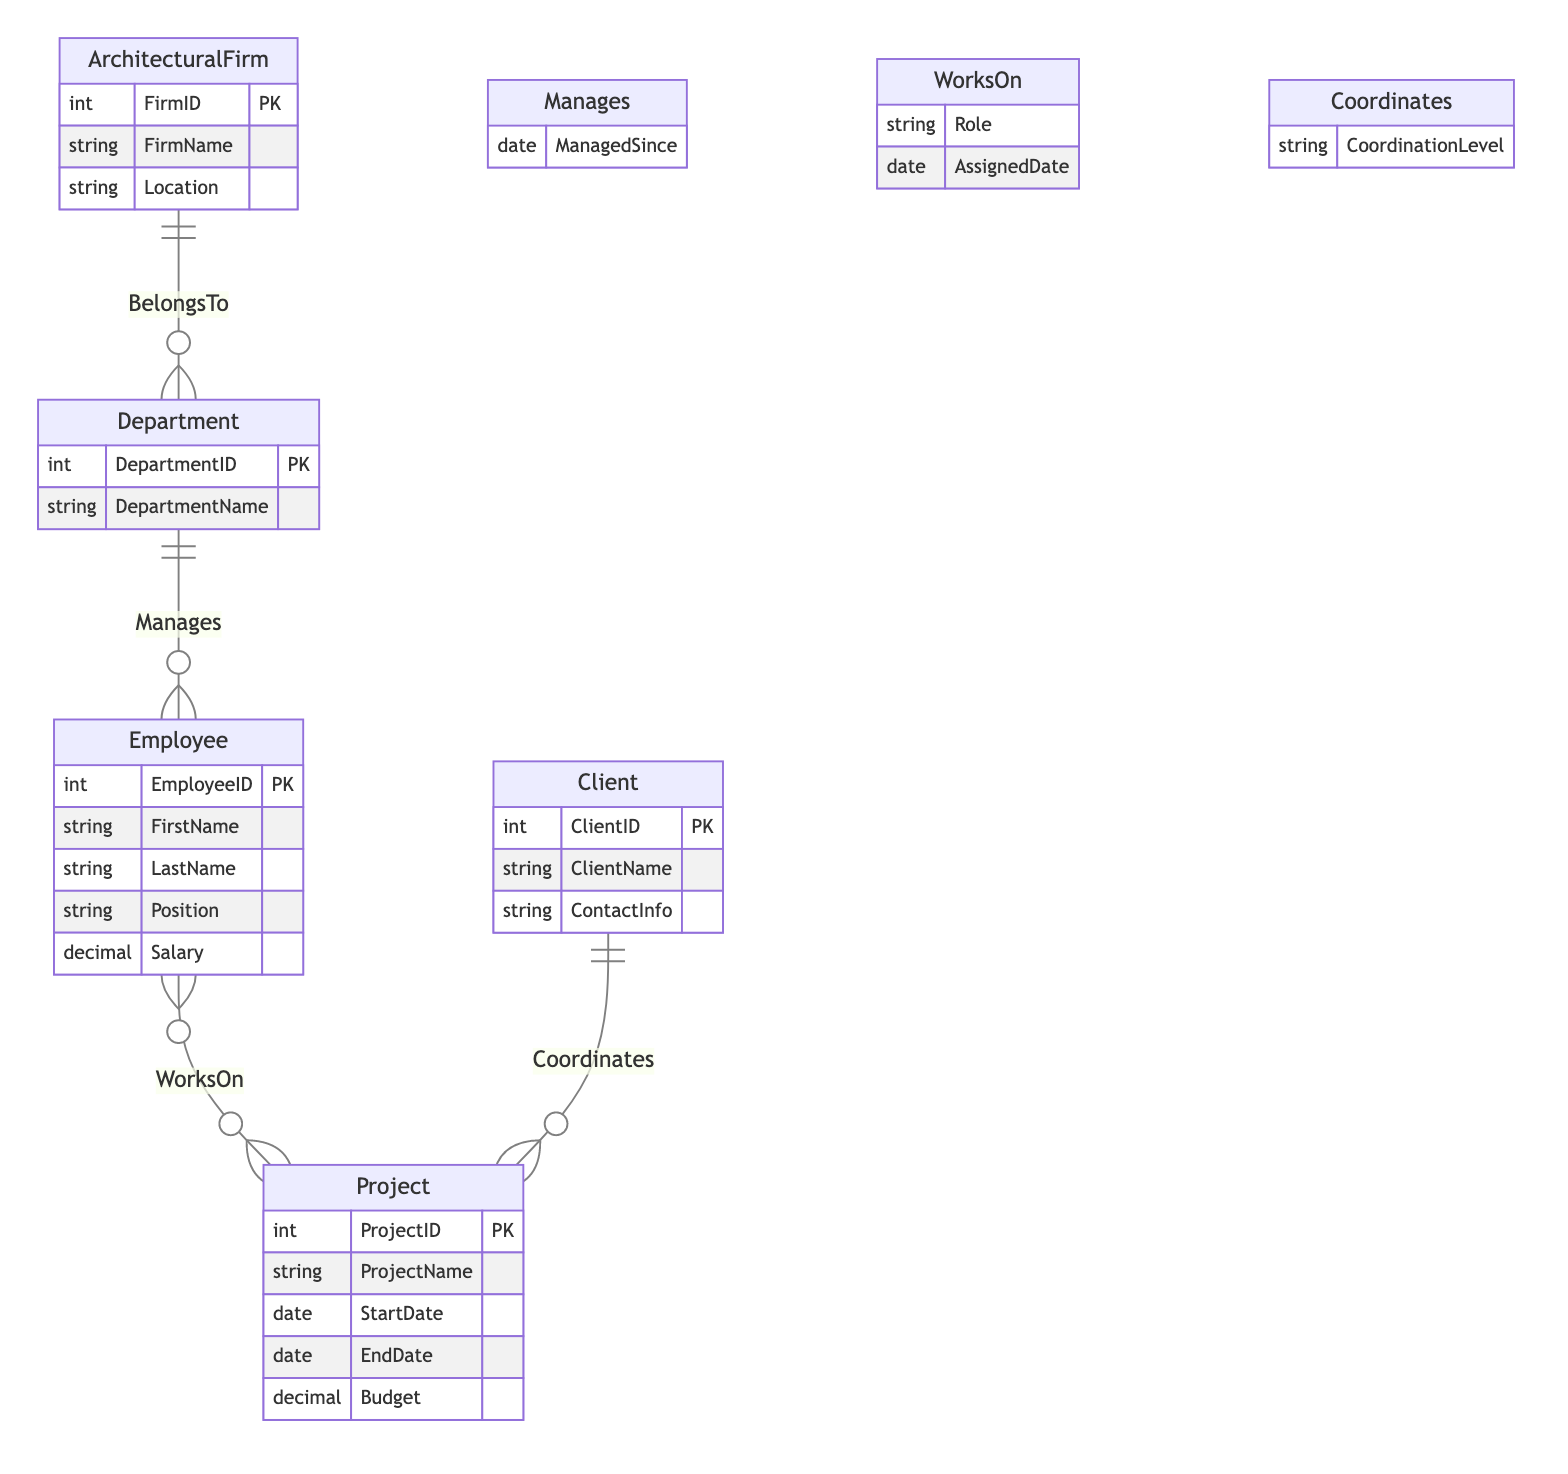What is the primary key of the Employee entity? The primary key of the Employee entity is EmployeeID, which uniquely identifies each employee in the table.
Answer: EmployeeID How many relationships are shown in the diagram? The diagram contains four relationships: BelongsTo, Manages, WorksOn, and Coordinates. Each of these defines a connection between distinct entities.
Answer: 4 Which entity has a cardinality of M:1 in relation to Department? The ArchitecturalFirm entity has a M:1 relationship in relation to the Department entity, indicating that each department belongs to one architectural firm but a firm can have multiple departments.
Answer: ArchitecturalFirm What does the WorksOn relationship represent? The WorksOn relationship signifies that multiple employees can work on multiple projects, which leads to a many-to-many association in the diagram.
Answer: Many-to-Many What attribute is associated with the Manages relationship? The Manages relationship has an attribute called ManagedSince, indicating the date when an employee started managing a department.
Answer: ManagedSince Which entity is responsible for coordinating projects with clients? The Project entity is responsible for coordination with clients through the Coordinates relationship, indicating the role of clients in projects.
Answer: Project How many attributes does the Client entity have? The Client entity has three attributes: ClientID, ClientName, and ContactInfo, which provide necessary details about a client.
Answer: 3 What are the possible roles in the WorksOn relationship? The WorksOn relationship includes an attribute called Role, which signifies the specific role of an employee in relation to a project.
Answer: Role What is the maximum number of departments that can belong to a single architectural firm? The maximum number is not explicitly defined in the diagram, but the M:1 cardinality suggests that multiple departments can belong to a single architectural firm.
Answer: Multiple 